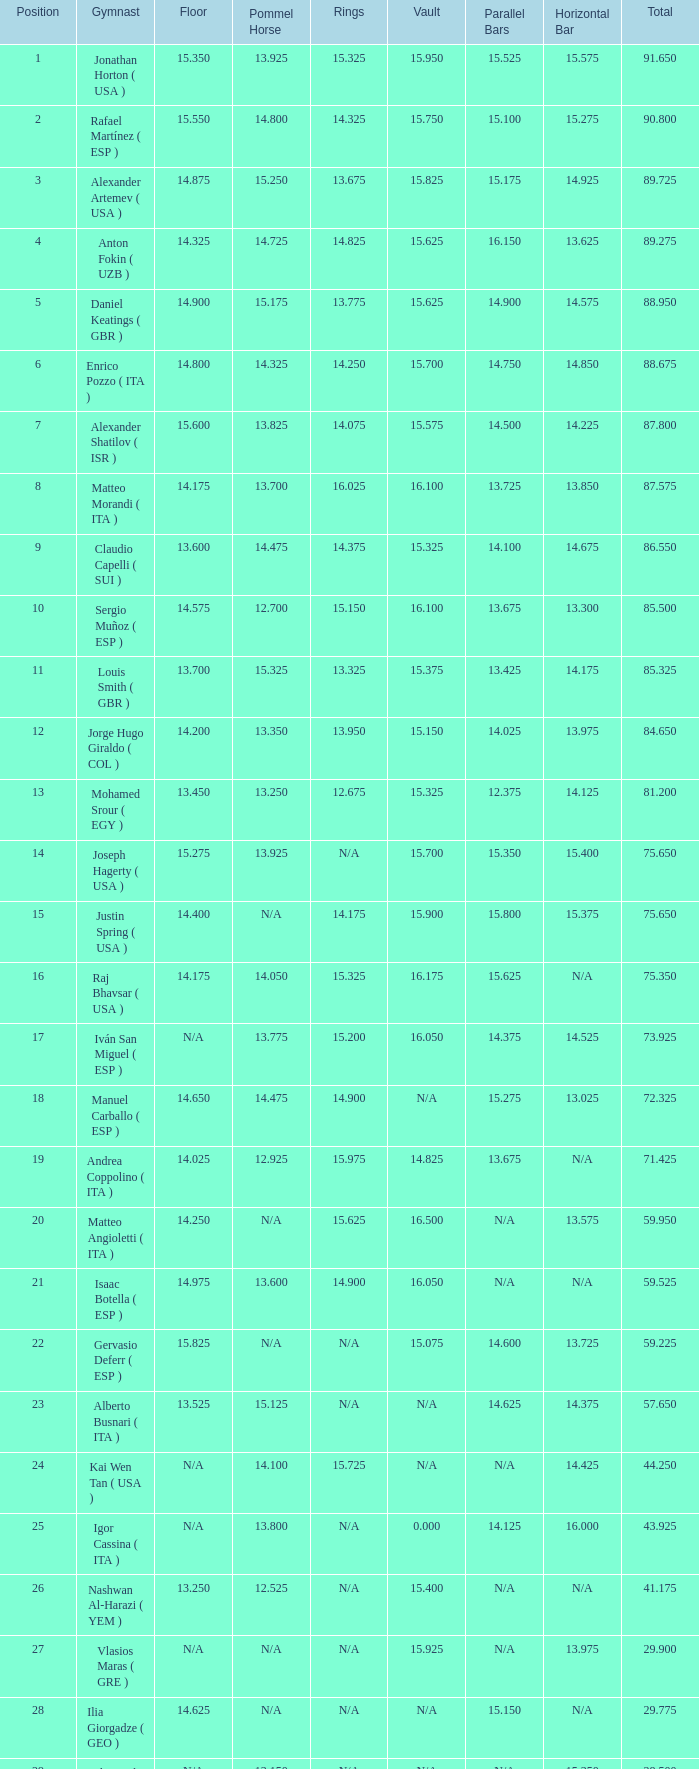If the parallel bars have a length of 1 1.0. 